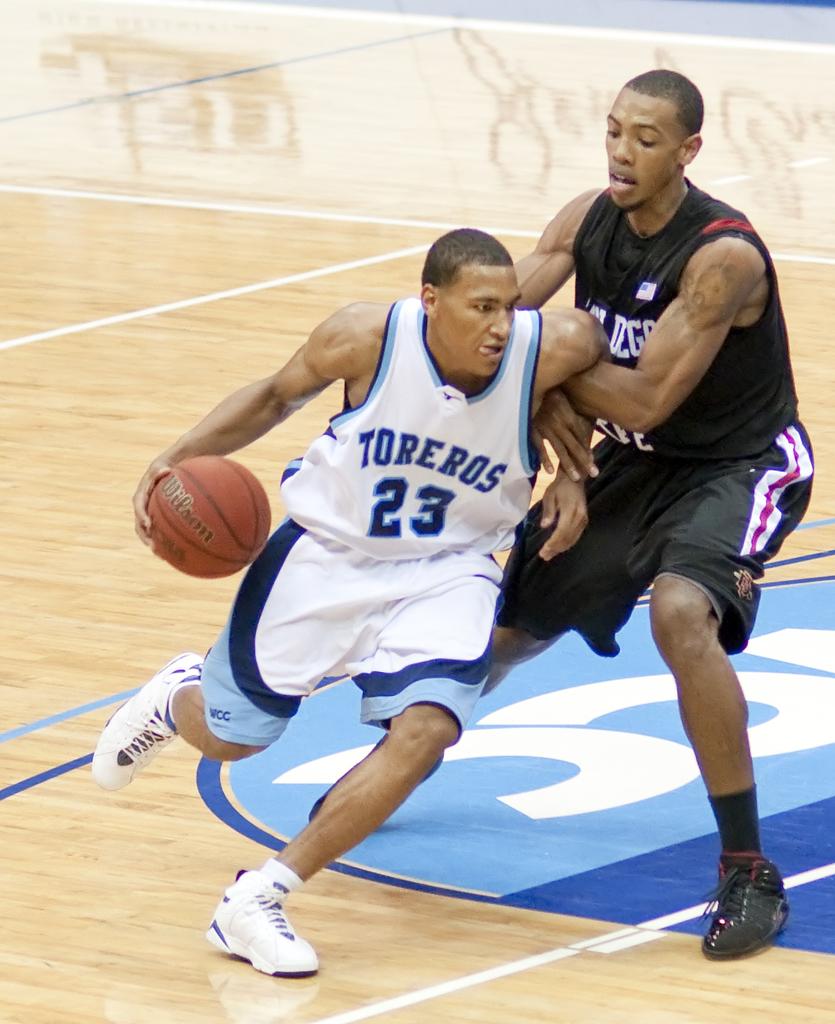What team does the player in white play for?
Your response must be concise. Toreros. What number is on the white jersey?
Make the answer very short. 23. 